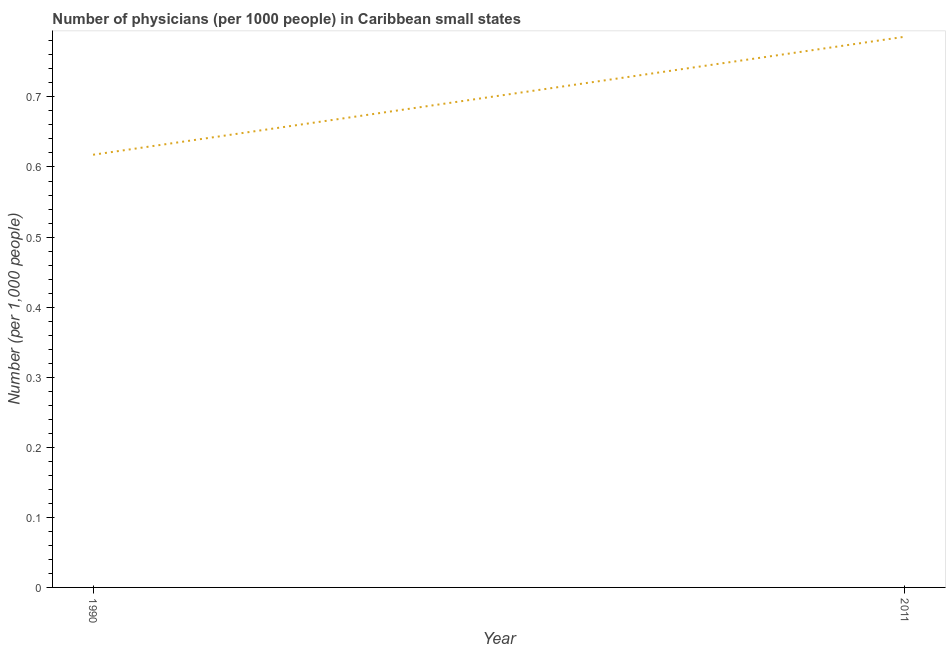What is the number of physicians in 2011?
Your answer should be compact. 0.79. Across all years, what is the maximum number of physicians?
Provide a short and direct response. 0.79. Across all years, what is the minimum number of physicians?
Your answer should be very brief. 0.62. What is the sum of the number of physicians?
Ensure brevity in your answer.  1.4. What is the difference between the number of physicians in 1990 and 2011?
Your answer should be very brief. -0.17. What is the average number of physicians per year?
Your answer should be compact. 0.7. What is the median number of physicians?
Give a very brief answer. 0.7. Do a majority of the years between 1990 and 2011 (inclusive) have number of physicians greater than 0.2 ?
Offer a very short reply. Yes. What is the ratio of the number of physicians in 1990 to that in 2011?
Ensure brevity in your answer.  0.79. How many lines are there?
Provide a short and direct response. 1. How many years are there in the graph?
Make the answer very short. 2. Does the graph contain grids?
Ensure brevity in your answer.  No. What is the title of the graph?
Make the answer very short. Number of physicians (per 1000 people) in Caribbean small states. What is the label or title of the Y-axis?
Your response must be concise. Number (per 1,0 people). What is the Number (per 1,000 people) in 1990?
Your answer should be very brief. 0.62. What is the Number (per 1,000 people) of 2011?
Ensure brevity in your answer.  0.79. What is the difference between the Number (per 1,000 people) in 1990 and 2011?
Provide a succinct answer. -0.17. What is the ratio of the Number (per 1,000 people) in 1990 to that in 2011?
Keep it short and to the point. 0.79. 